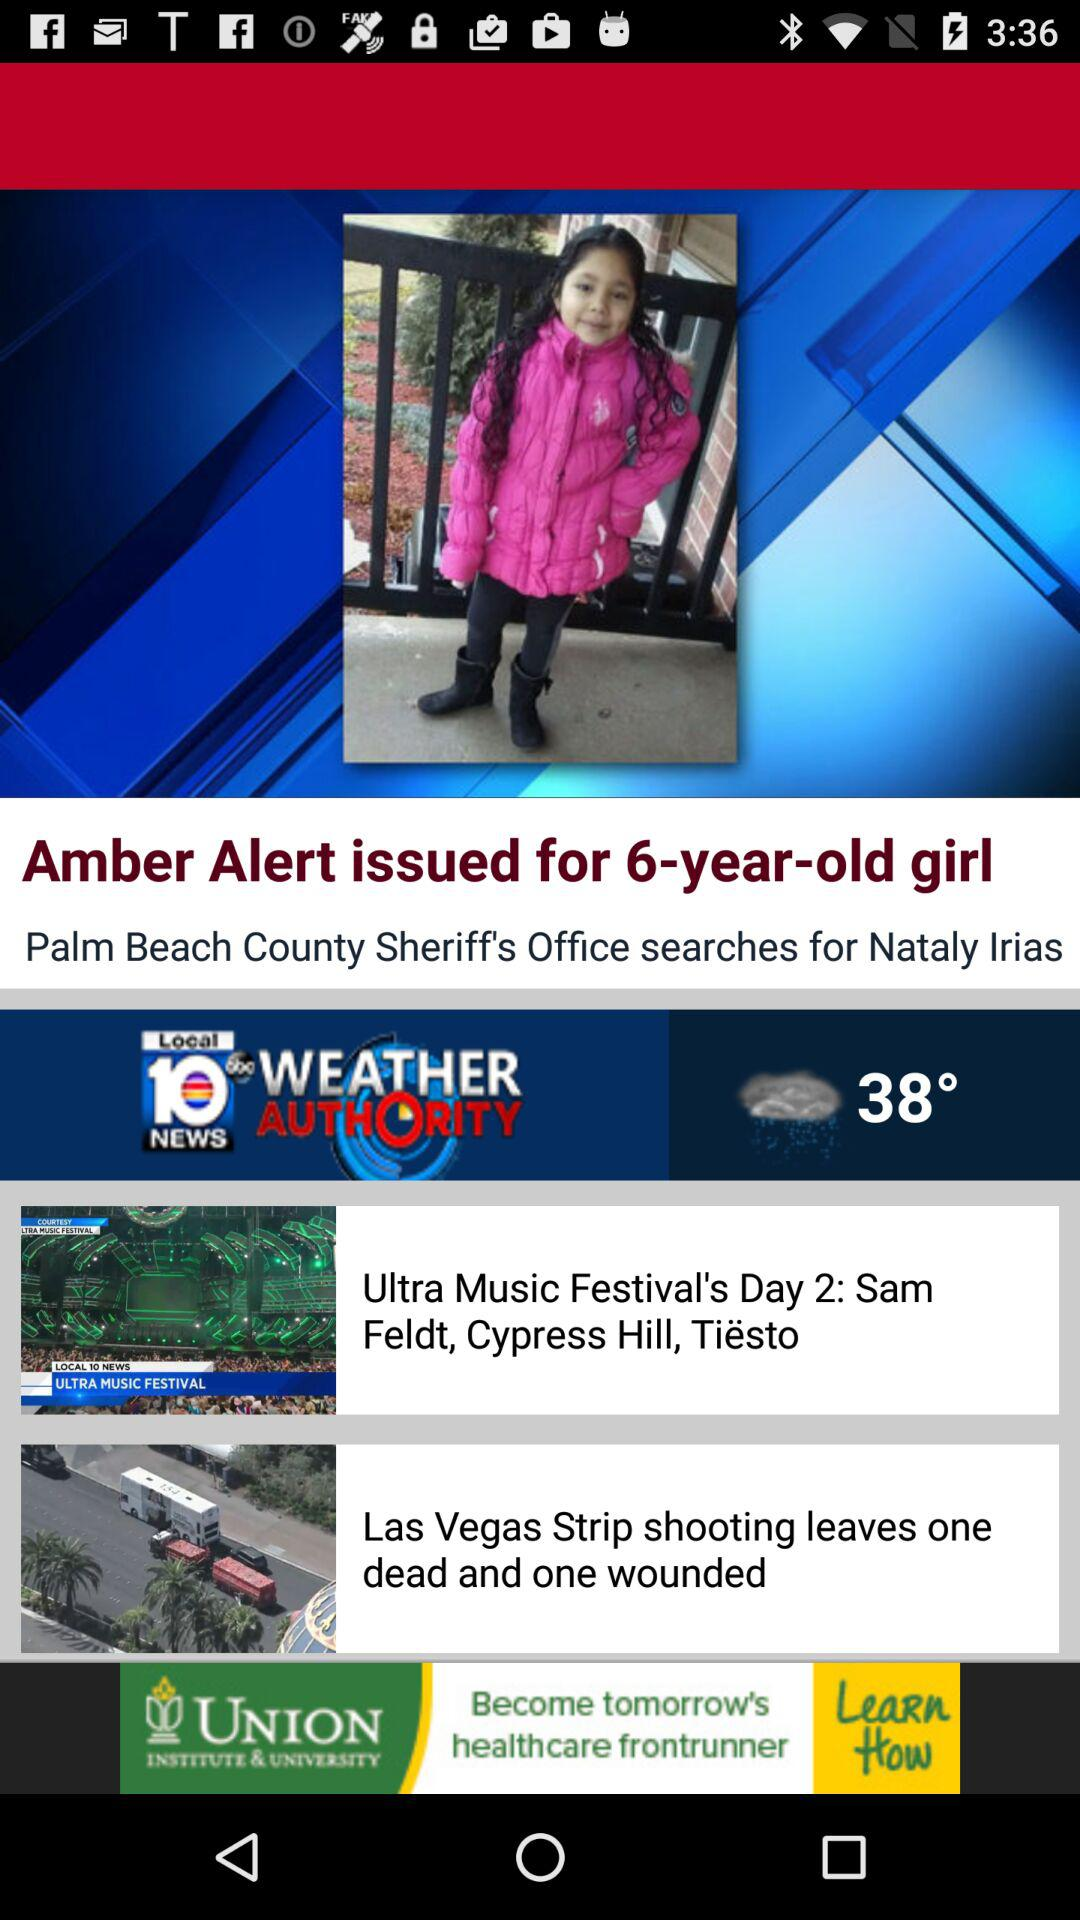What is the app name? The app name is "Local 10 News WEATHER AUTHORITY". 